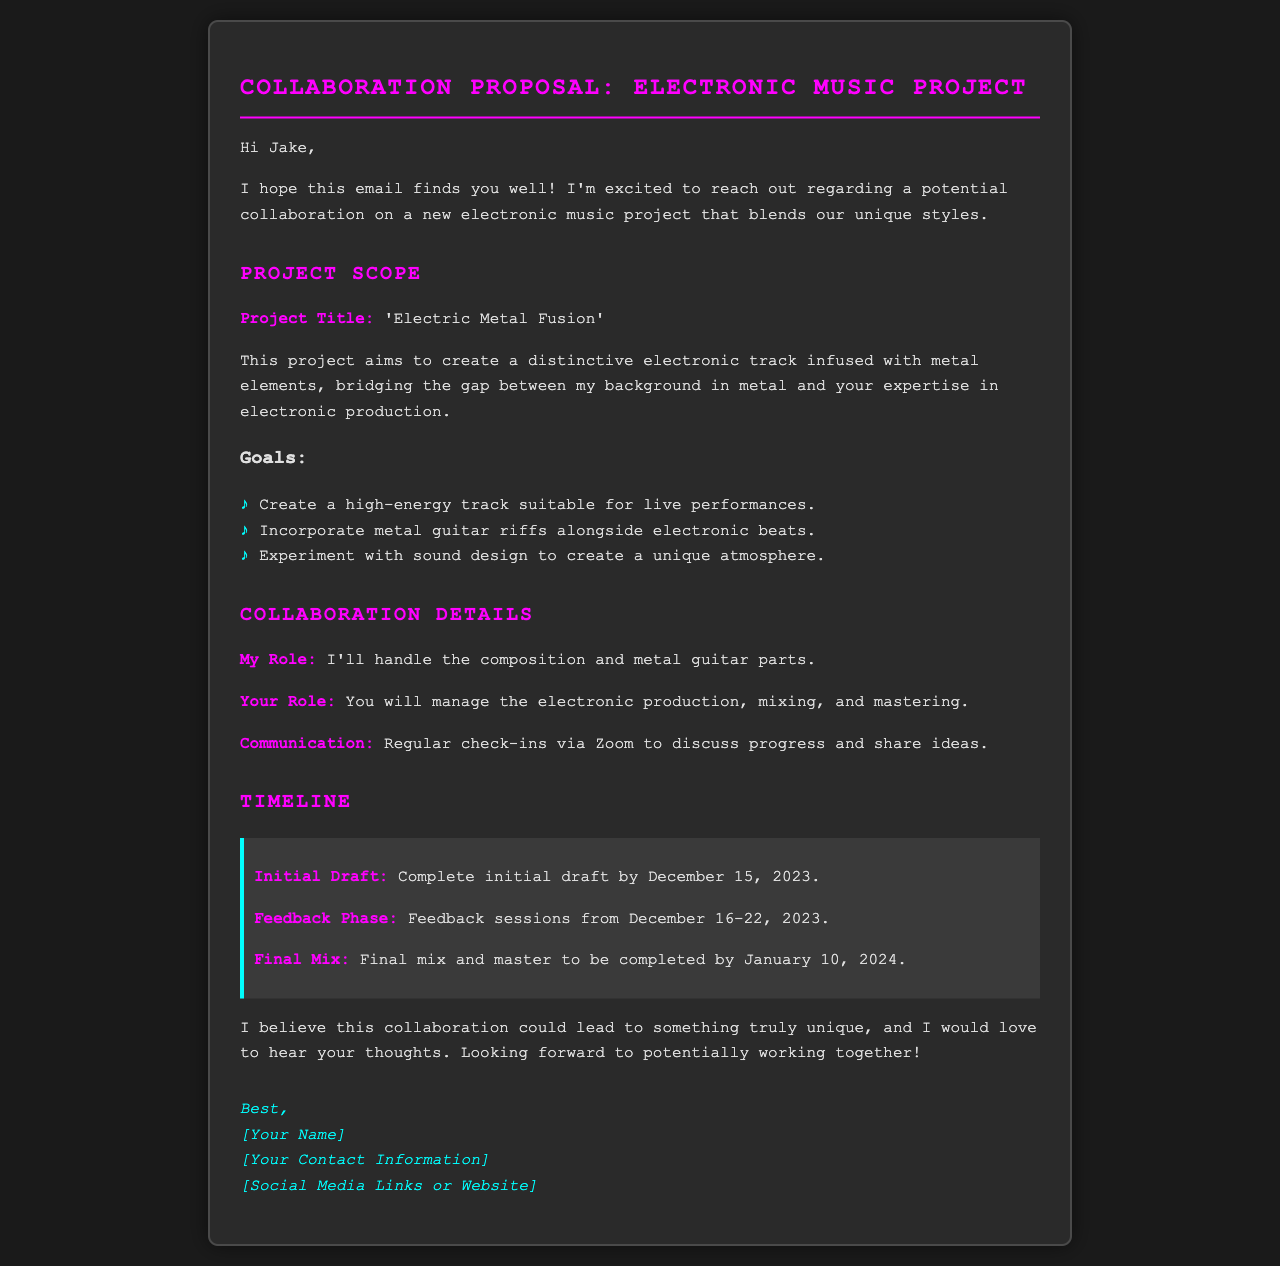what is the project title? The project title is presented as a highlighted section in the document.
Answer: 'Electric Metal Fusion' who is responsible for the composition? The document specifies individual roles in the project, pointing the responsibility for composition.
Answer: I when is the initial draft due? The document lists specific deadlines for different phases of the project, including the initial draft.
Answer: December 15, 2023 what is the feedback phase duration? The feedback phase is detailed in the document, listing the specific dates allocated for this phase.
Answer: December 16-22, 2023 what type of track is being created? The document describes the nature of the track that is the focus of the collaboration proposal.
Answer: electronic track what will be incorporated into the track? The document outlines key elements that will be included in the project, giving a clear picture of the musical style.
Answer: metal guitar riffs and electronic beats how will communication be maintained? The proposal mentions the method of communication that will be used throughout the collaboration.
Answer: Zoom when will the final mix be completed? The timeline section of the document states when the final mixing and mastering are set to be done.
Answer: January 10, 2024 